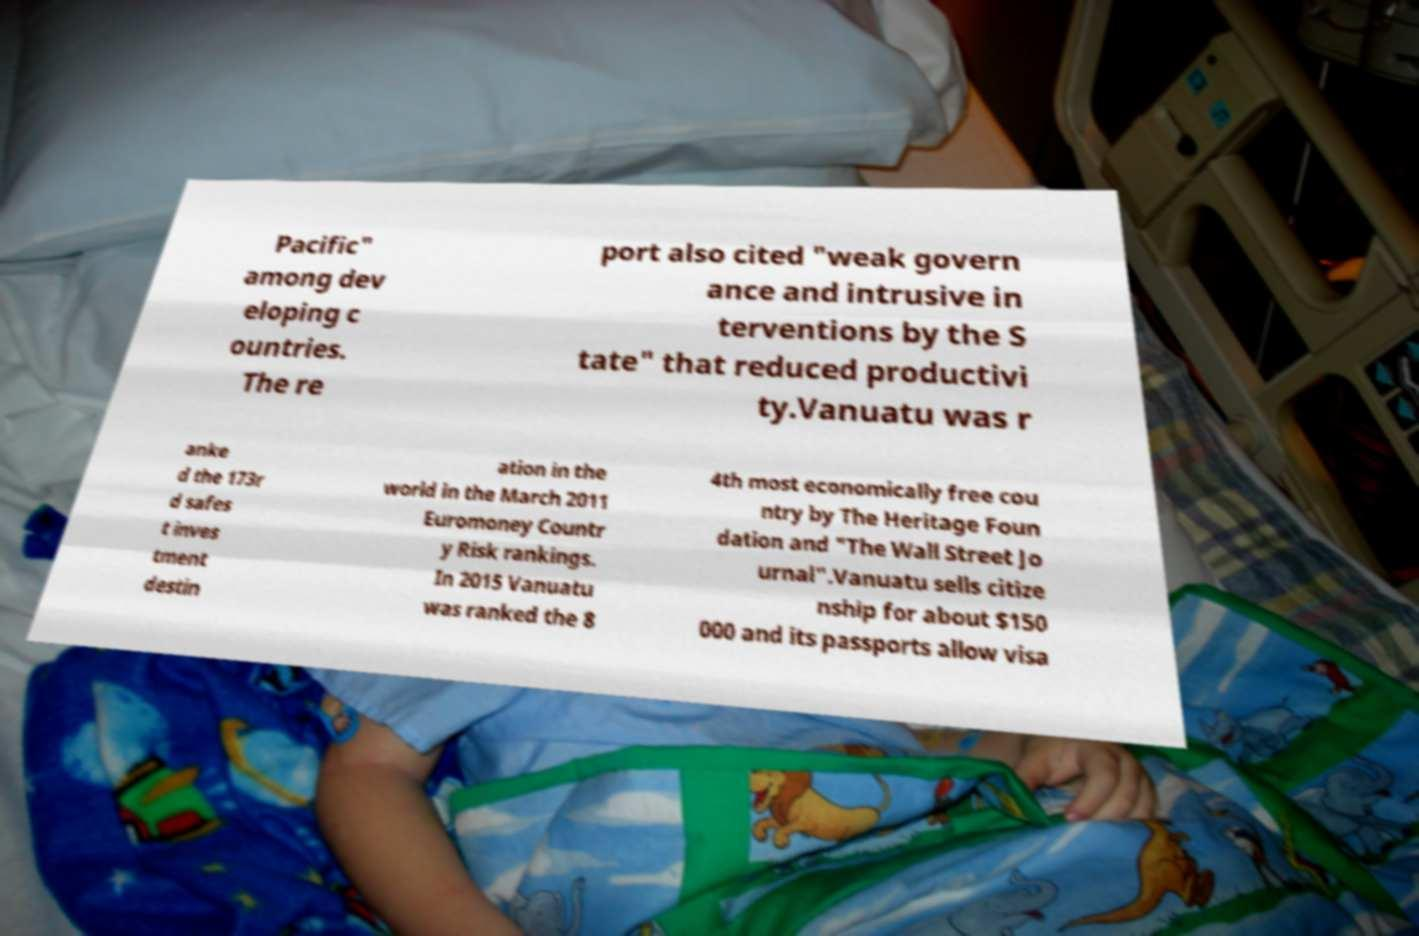Please identify and transcribe the text found in this image. Pacific" among dev eloping c ountries. The re port also cited "weak govern ance and intrusive in terventions by the S tate" that reduced productivi ty.Vanuatu was r anke d the 173r d safes t inves tment destin ation in the world in the March 2011 Euromoney Countr y Risk rankings. In 2015 Vanuatu was ranked the 8 4th most economically free cou ntry by The Heritage Foun dation and "The Wall Street Jo urnal".Vanuatu sells citize nship for about $150 000 and its passports allow visa 